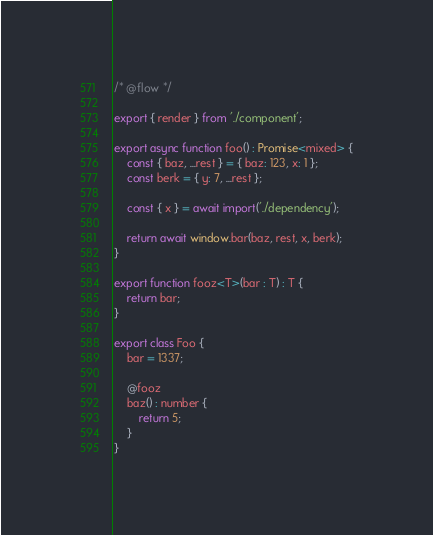Convert code to text. <code><loc_0><loc_0><loc_500><loc_500><_JavaScript_>/* @flow */

export { render } from './component';

export async function foo() : Promise<mixed> {
    const { baz, ...rest } = { baz: 123, x: 1 };
    const berk = { y: 7, ...rest };

    const { x } = await import('./dependency');

    return await window.bar(baz, rest, x, berk);
}

export function fooz<T>(bar : T) : T {
    return bar;
}

export class Foo {
    bar = 1337;

    @fooz
    baz() : number {
        return 5;
    }
}
</code> 